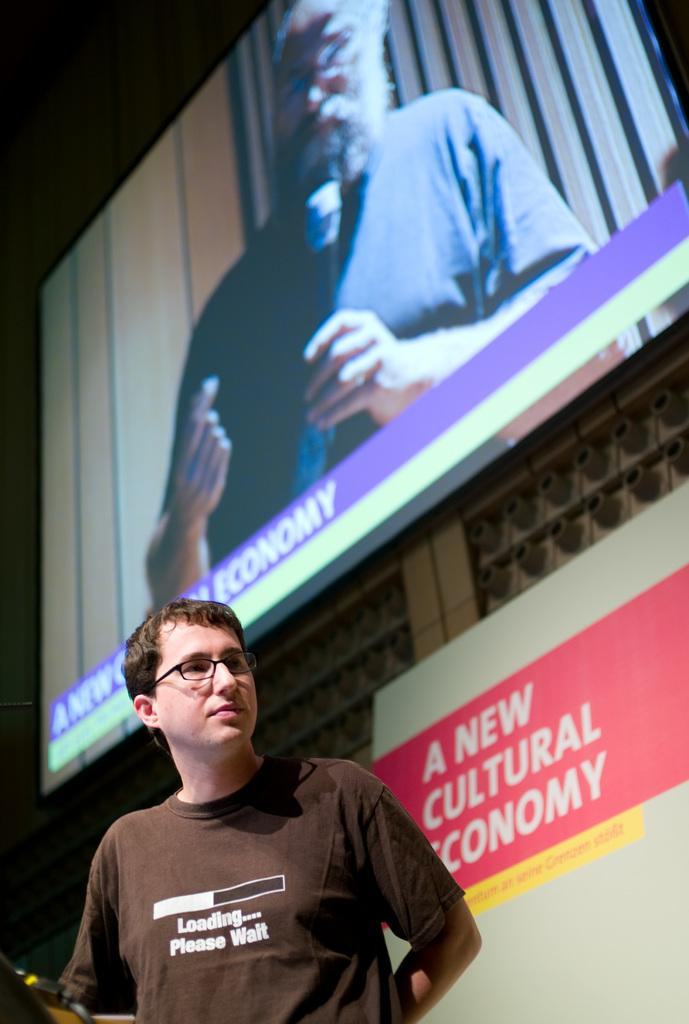What can be seen in the image? There is a person in the image. Can you describe the person's clothing? The person is wearing a brown shirt. Are there any accessories visible on the person? Yes, the person is wearing spectacles. What is in the background of the image? There is a wall with a screen in the background. What is displayed on the screen? The screen displays a picture of a person holding a microphone in their hand. What type of leather is visible on the doll in the park? There is no doll or park present in the image. The image features a person with a brown shirt, spectacles, and a screen displaying a person holding a microphone in the background. 